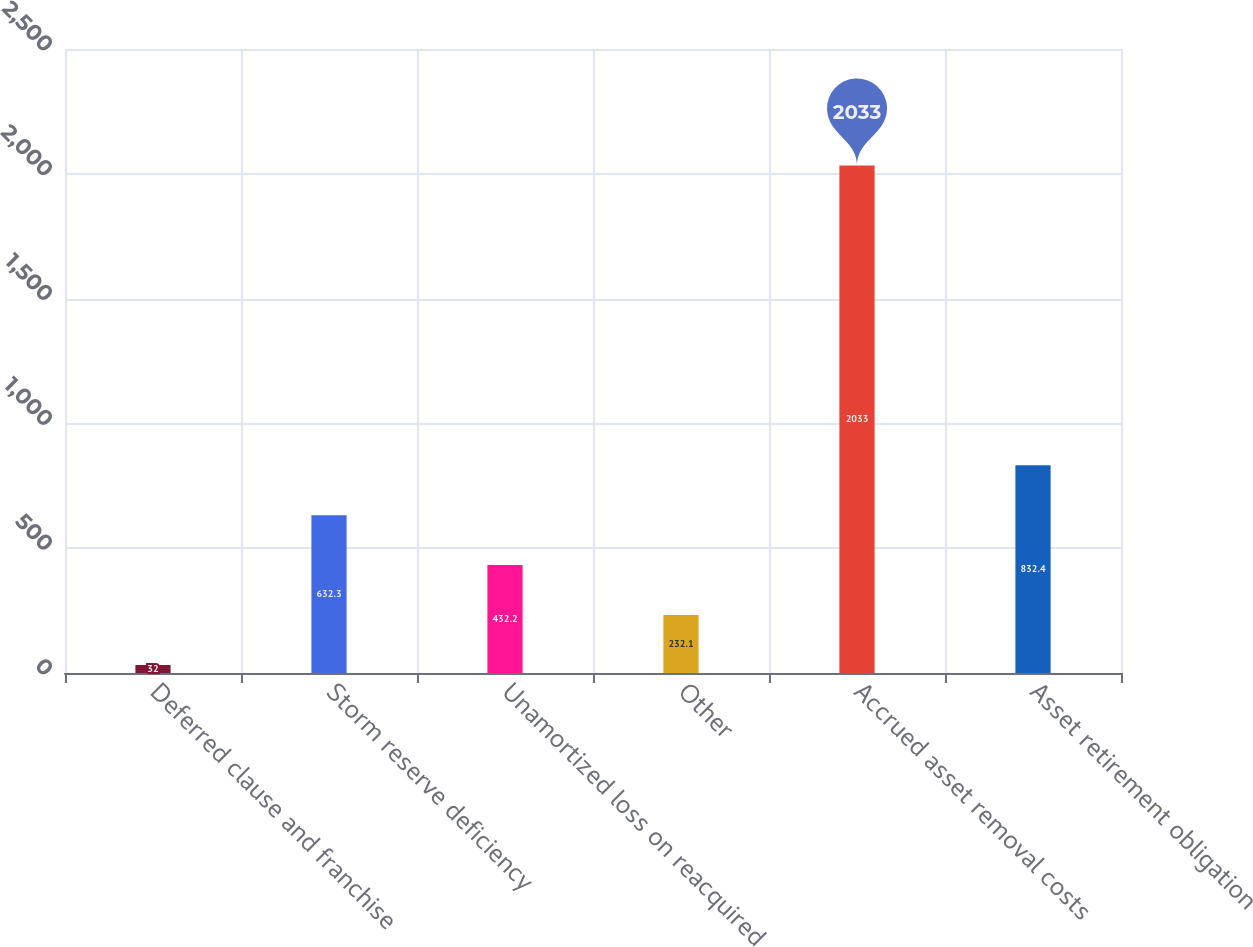Convert chart. <chart><loc_0><loc_0><loc_500><loc_500><bar_chart><fcel>Deferred clause and franchise<fcel>Storm reserve deficiency<fcel>Unamortized loss on reacquired<fcel>Other<fcel>Accrued asset removal costs<fcel>Asset retirement obligation<nl><fcel>32<fcel>632.3<fcel>432.2<fcel>232.1<fcel>2033<fcel>832.4<nl></chart> 